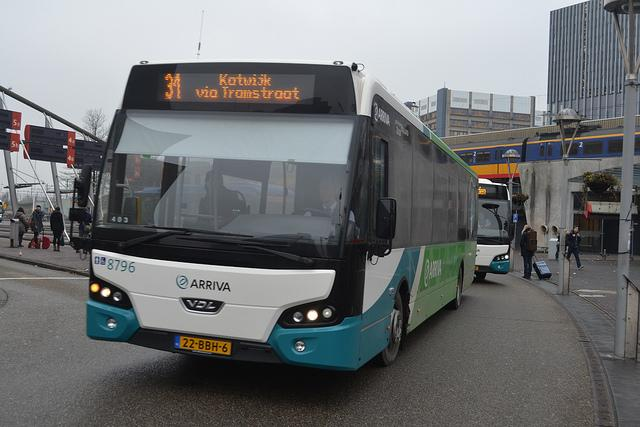Which animal would weigh more than this vehicle if it had no passengers?

Choices:
A) giraffe
B) elephant
C) bison
D) diplodocus diplodocus 